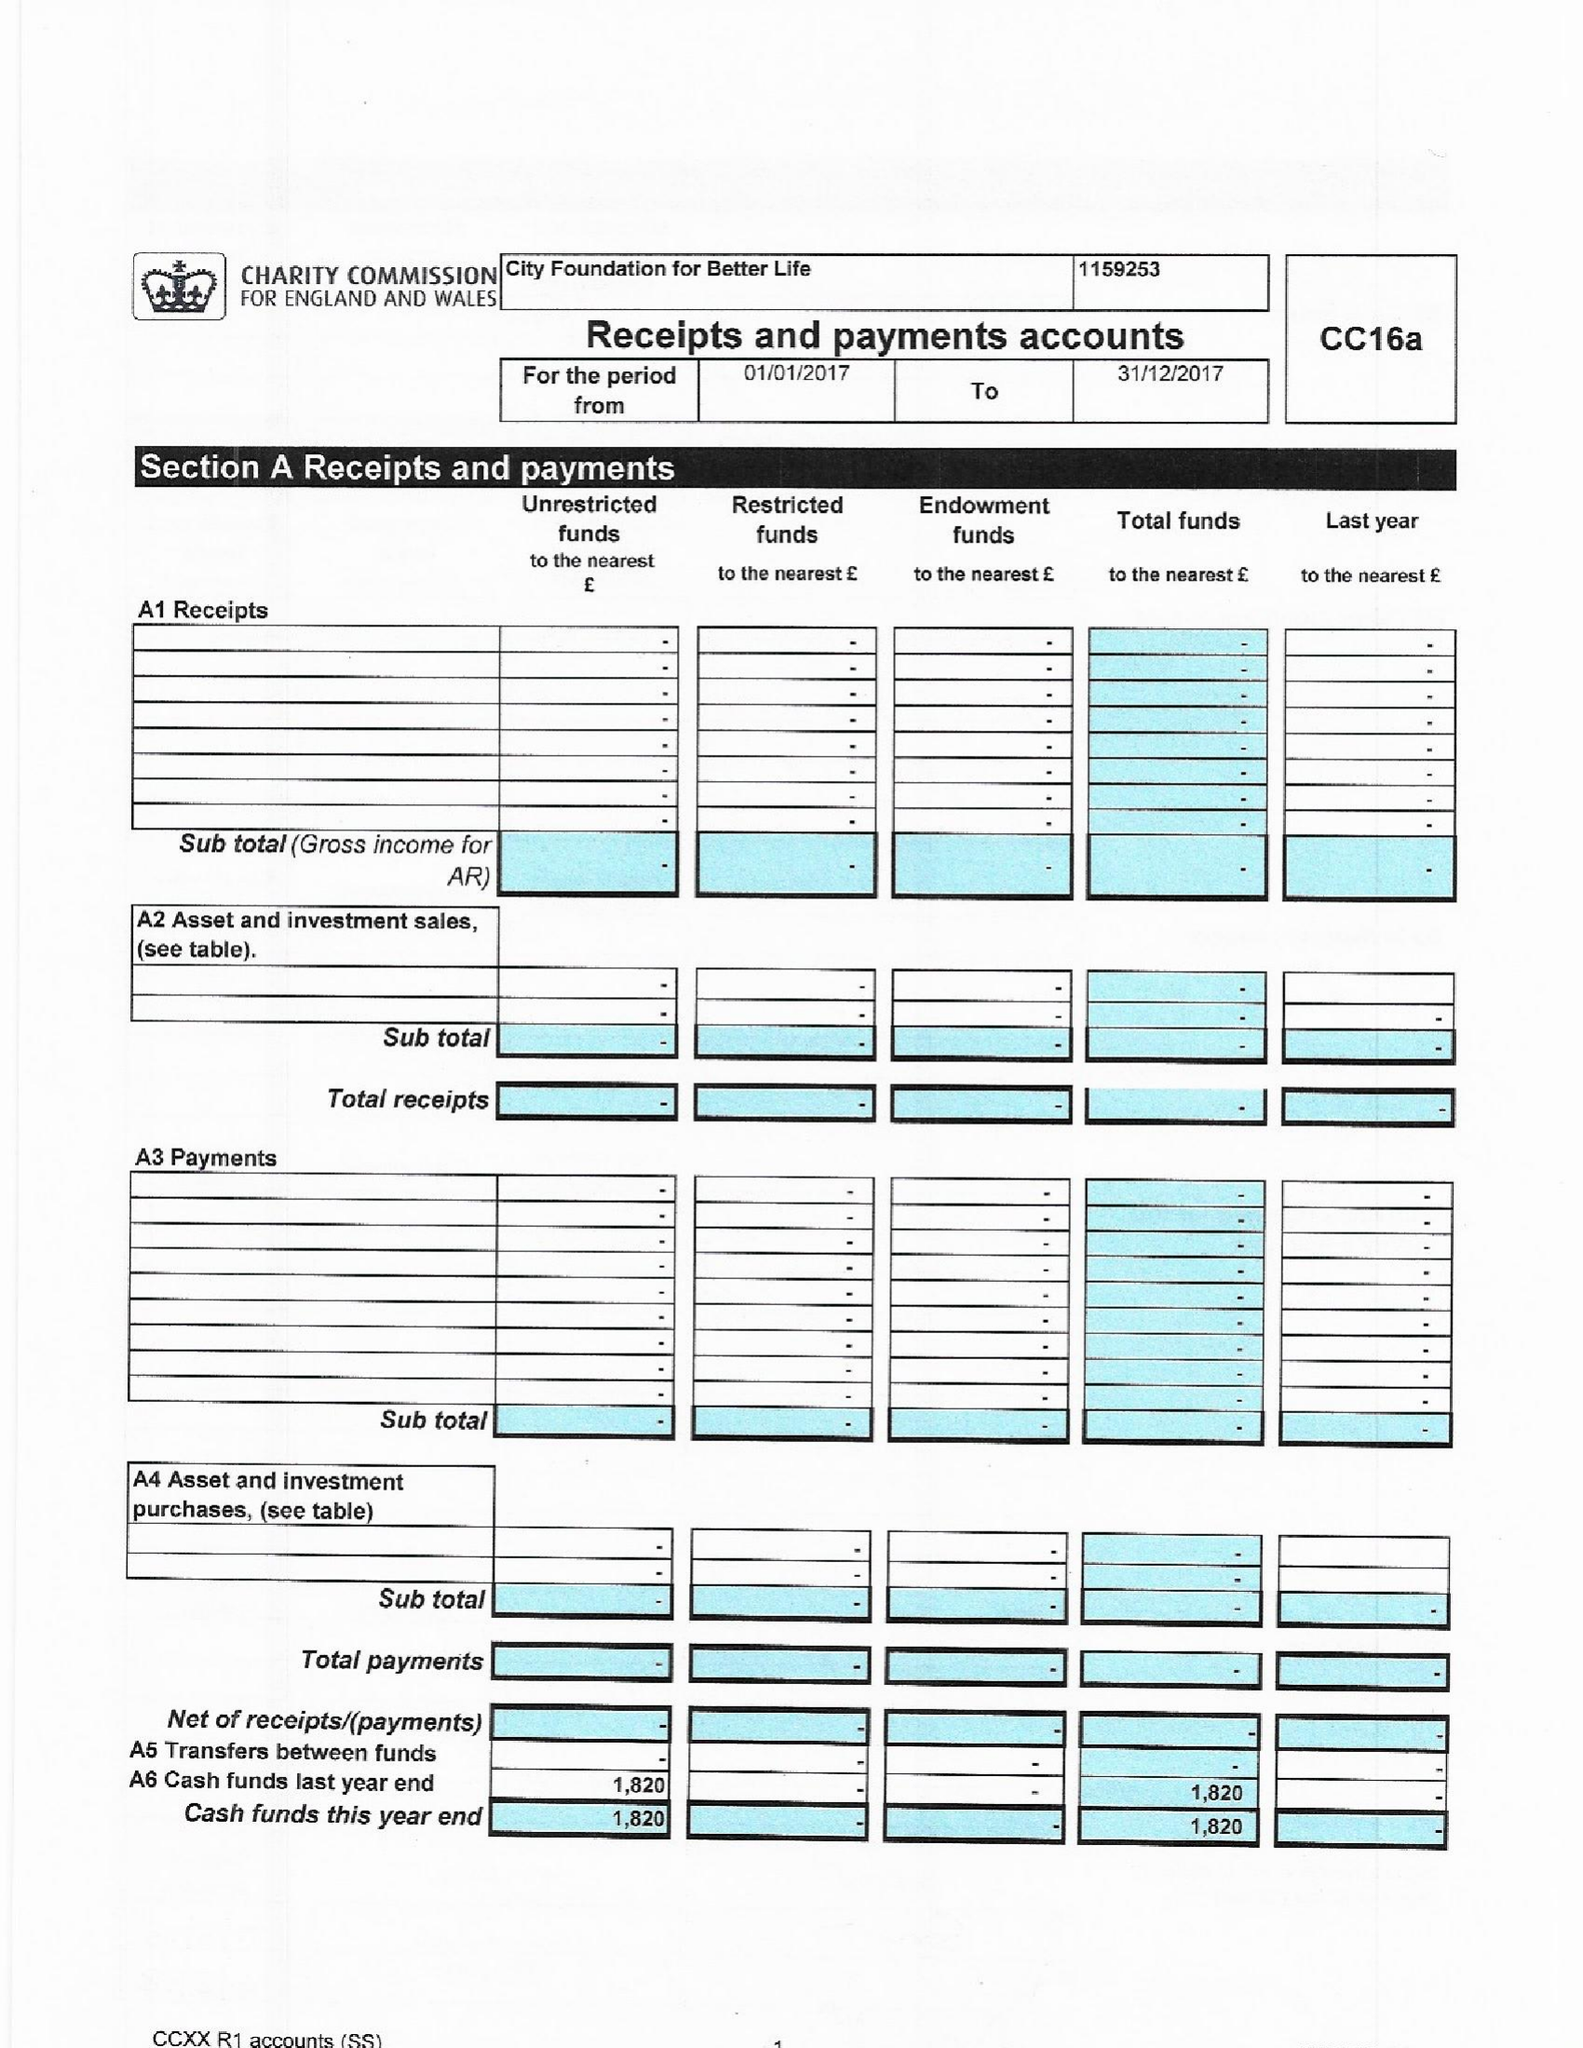What is the value for the address__postcode?
Answer the question using a single word or phrase. KT3 4JZ 